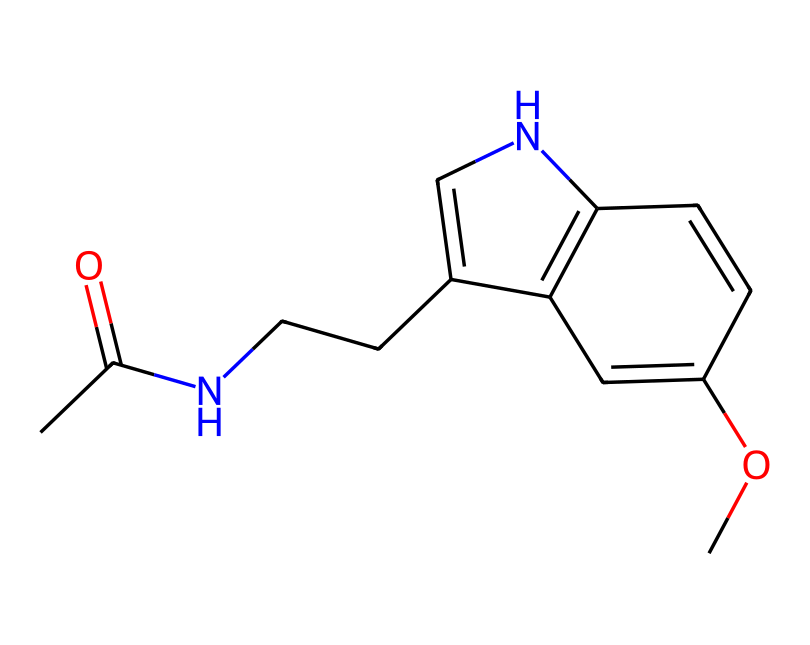What is the main functional group present in this molecule? The structure contains an amide group (as indicated by the carbonyl and nitrogen connected to the carbon chain), which is a defining feature of melatonin.
Answer: amide How many nitrogen atoms are present in the molecule? By examining the structure, we can identify two nitrogen atoms, one in the cyclic structure and another within the amide group.
Answer: two What is the molecular formula represented by this structure? Counting the atoms from the structure gives us a total of 13 carbon, 16 hydrogen, and 2 nitrogen atoms, leading to the molecular formula C13H16N2O.
Answer: C13H16N2O Does this molecule have a cyclic structure? The presence of a ring in the chemical structure indicates that it is indeed a cyclic compound, characteristic of many neurotransmitters, including melatonin.
Answer: yes What type of isomerism could this molecule exhibit? Given its structure, it has multiple functional groups which could lead to potential geometric or stereoisomerism due to the presence of double bonds and chiral centers in the cyclic parts.
Answer: stereoisomerism What type of chemical is this according to its primary function? Evaluating the overall structure and its known effects on biological systems, this compound primarily acts as a hormone or neurotransmitter related to sleep regulation, specifically melatonin.
Answer: hormone 